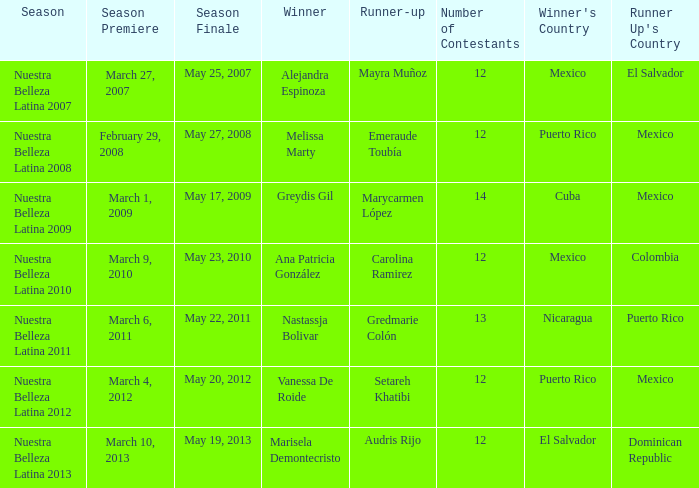I'm looking to parse the entire table for insights. Could you assist me with that? {'header': ['Season', 'Season Premiere', 'Season Finale', 'Winner', 'Runner-up', 'Number of Contestants', "Winner's Country", "Runner Up's Country"], 'rows': [['Nuestra Belleza Latina 2007', 'March 27, 2007', 'May 25, 2007', 'Alejandra Espinoza', 'Mayra Muñoz', '12', 'Mexico', 'El Salvador'], ['Nuestra Belleza Latina 2008', 'February 29, 2008', 'May 27, 2008', 'Melissa Marty', 'Emeraude Toubía', '12', 'Puerto Rico', 'Mexico'], ['Nuestra Belleza Latina 2009', 'March 1, 2009', 'May 17, 2009', 'Greydis Gil', 'Marycarmen López', '14', 'Cuba', 'Mexico'], ['Nuestra Belleza Latina 2010', 'March 9, 2010', 'May 23, 2010', 'Ana Patricia González', 'Carolina Ramirez', '12', 'Mexico', 'Colombia'], ['Nuestra Belleza Latina 2011', 'March 6, 2011', 'May 22, 2011', 'Nastassja Bolivar', 'Gredmarie Colón', '13', 'Nicaragua', 'Puerto Rico'], ['Nuestra Belleza Latina 2012', 'March 4, 2012', 'May 20, 2012', 'Vanessa De Roide', 'Setareh Khatibi', '12', 'Puerto Rico', 'Mexico'], ['Nuestra Belleza Latina 2013', 'March 10, 2013', 'May 19, 2013', 'Marisela Demontecristo', 'Audris Rijo', '12', 'El Salvador', 'Dominican Republic']]} In the season that alejandra espinoza emerged as the winner, how many contestants took part? 1.0. 